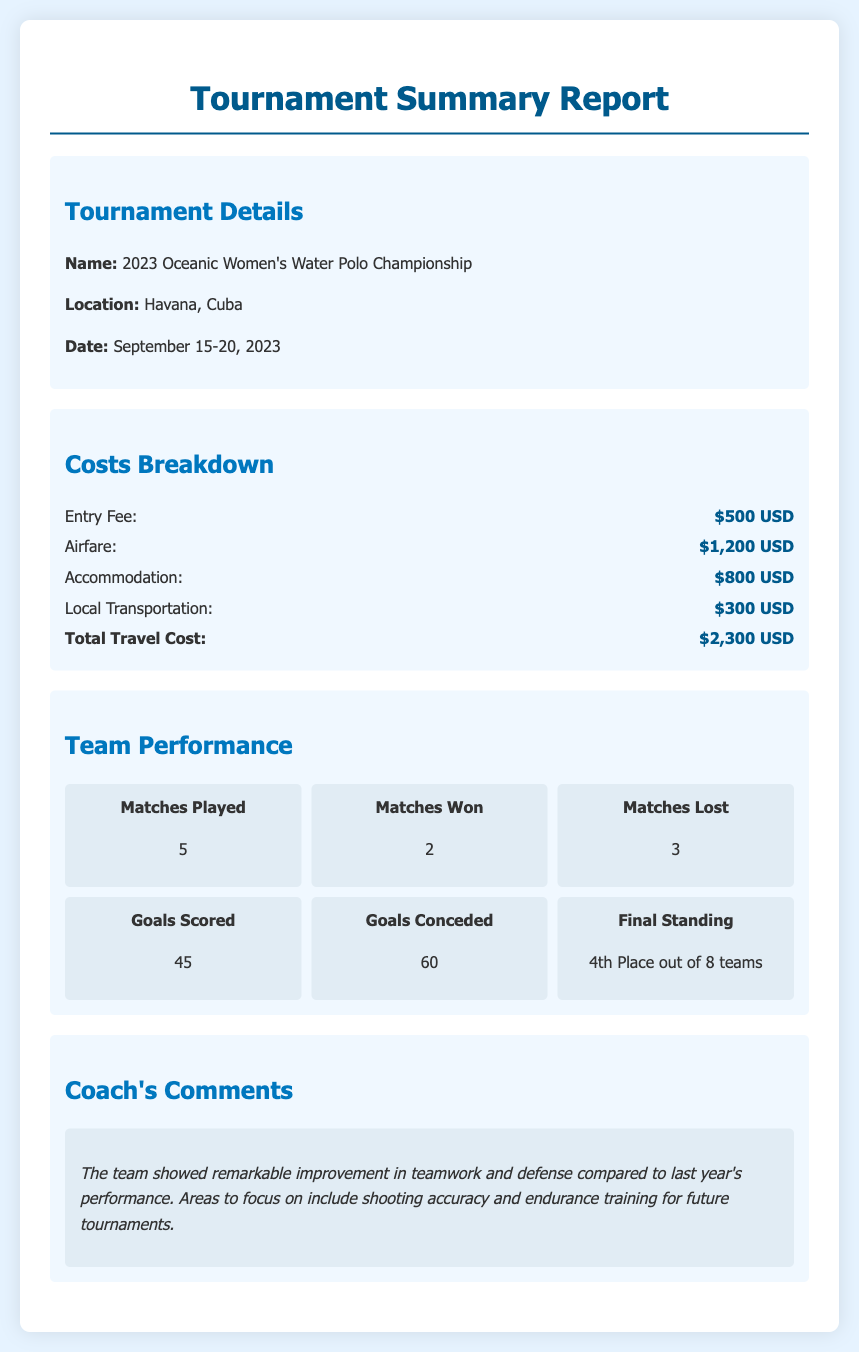What is the name of the tournament? The name of the tournament is listed under the Tournament Details section.
Answer: 2023 Oceanic Women's Water Polo Championship What is the total travel cost? The total travel cost is calculated by adding all the costs related to travel in the Costs Breakdown section.
Answer: $2,300 USD How many matches were won by the team? The number of matches won is found in the Team Performance section detailing the performance metrics.
Answer: 2 What was the team's final standing? The final standing is specified in the Team Performance section, outlining the team's rank in the tournament.
Answer: 4th Place out of 8 teams What is the airfare cost? The airfare cost is one of the items listed in the breakdown of costs under the Costs Breakdown section.
Answer: $1,200 USD Which area does the coach suggest to improve on? The coach's comments highlight specific areas for improvement found in the Coach's Comments section.
Answer: Shooting accuracy How many goals were scored by the team? The total goals scored is indicated in the Team Performance section.
Answer: 45 Where was the tournament held? The location of the tournament can be found in the Tournament Details section.
Answer: Havana, Cuba 